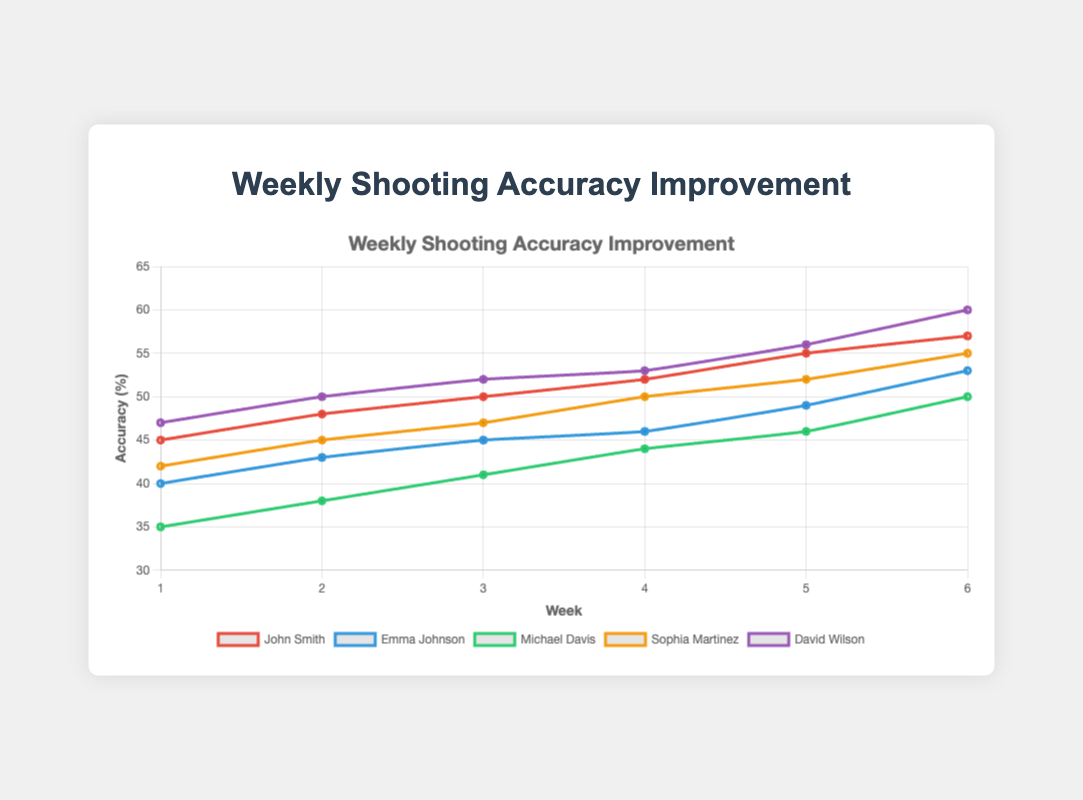Which marksman showed the highest improvement in accuracy from Week 1 to Week 6? To determine this, find the improvement in accuracy for each marksman by subtracting Week 1 accuracy from Week 6 accuracy for each person. Then compare these values. John improves by 12 (57-45), Emma by 13 (53-40), Michael by 15 (50-35), Sophia by 13 (55-42), and David by 13 (60-47). Michael showed the highest improvement of 15.
Answer: Michael Davis How does John Smith's accuracy in Week 3 compare to Emma Johnson's in the same week? Look at Week 3 data points for both John Smith and Emma Johnson. John has an accuracy of 50, while Emma has 45. John's accuracy in Week 3 is greater than Emma's.
Answer: John's accuracy is higher Which marksman has a steeper improvement rate from Week 3 to Week 6: David Wilson or Sophia Martinez? To find who has a steeper improvement rate, calculate the difference in accuracy between Week 3 and Week 6 for David and Sophia. For David, it's 60-52=8, and for Sophia, it's 55-47=8. Both have the same improvement rate in this period.
Answer: Both have the same rate What is the average accuracy improvement from Week 4 to Week 6 for all marksmen? To calculate this, find the improvement from Week 4 to Week 6 for each marksman and then find the average of these improvements. John: 57-52=5, Emma: 53-46=7, Michael: 50-44=6, Sophia: 55-50=5, David: 60-53=7. The average is (5+7+6+5+7)/5=6.
Answer: 6 Compare the accuracy of Michael Davis in Week 1 and Week 6 with that of David Wilson in the same weeks. Look at accuracy values for Michael and David in Week 1 and Week 6. Michael: 35 in Week 1 and 50 in Week 6. David: 47 in Week 1 and 60 in Week 6. David starts higher and ends higher compared to Michael.
Answer: David is higher in both Which marksman had the smallest improvement between any two consecutive weeks, and what was the value? Analyze accuracy changes between any two consecutive weeks for each marksman. The smallest change is between Week 3 and Week 4 for Emma, which is 46-45=1.
Answer: Emma Johnson, 1 Who had an accuracy closest to 50% in Week 5? Compare the accuracy of all marksmen in Week 5. John: 55, Emma: 49, Michael: 46, Sophia: 52, David: 56. Emma Johnson's accuracy of 49 is closest to 50%.
Answer: Emma Johnson 